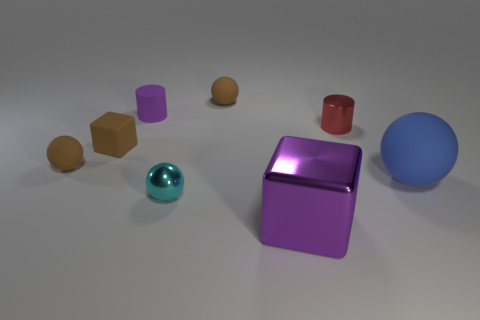How many other objects are the same material as the large sphere?
Give a very brief answer. 4. There is a small matte object that is the same color as the big metal thing; what is its shape?
Your answer should be very brief. Cylinder. There is a brown rubber sphere that is to the left of the matte cylinder; how big is it?
Keep it short and to the point. Small. There is a purple thing that is the same material as the cyan thing; what shape is it?
Provide a short and direct response. Cube. Does the big purple object have the same material as the brown ball that is to the left of the tiny cyan metallic object?
Your response must be concise. No. There is a shiny object that is behind the blue ball; does it have the same shape as the blue matte object?
Provide a short and direct response. No. Are there the same number of small brown rubber spheres and big metal objects?
Offer a terse response. No. What is the material of the tiny red object that is the same shape as the small purple object?
Your response must be concise. Metal. There is a large purple object; does it have the same shape as the tiny shiny object behind the small cyan sphere?
Offer a terse response. No. What is the color of the ball that is both in front of the tiny metal cylinder and to the right of the cyan metal ball?
Offer a very short reply. Blue. 